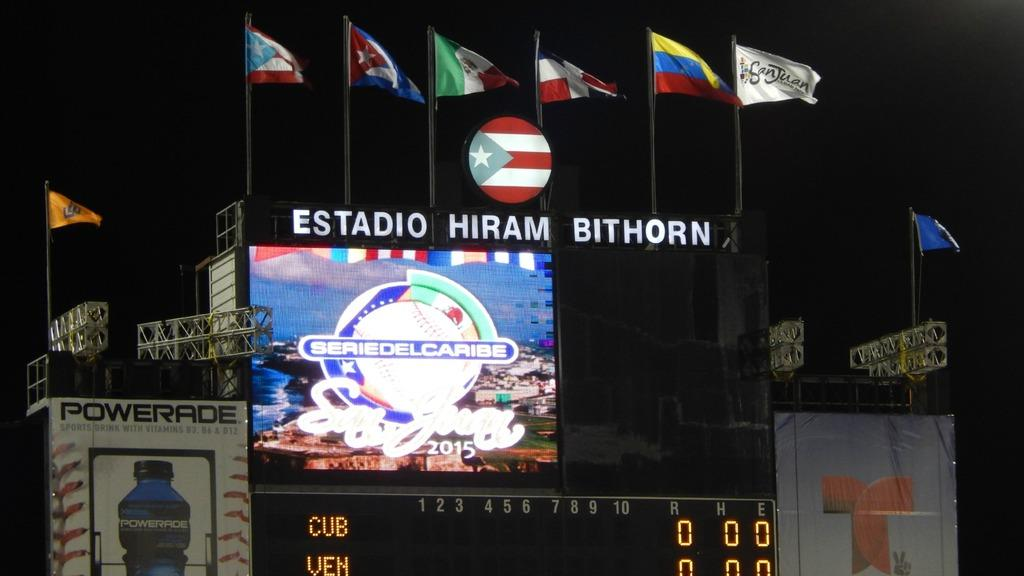<image>
Share a concise interpretation of the image provided. a stadium board with the word Estadio on it 